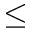<formula> <loc_0><loc_0><loc_500><loc_500>\leq</formula> 